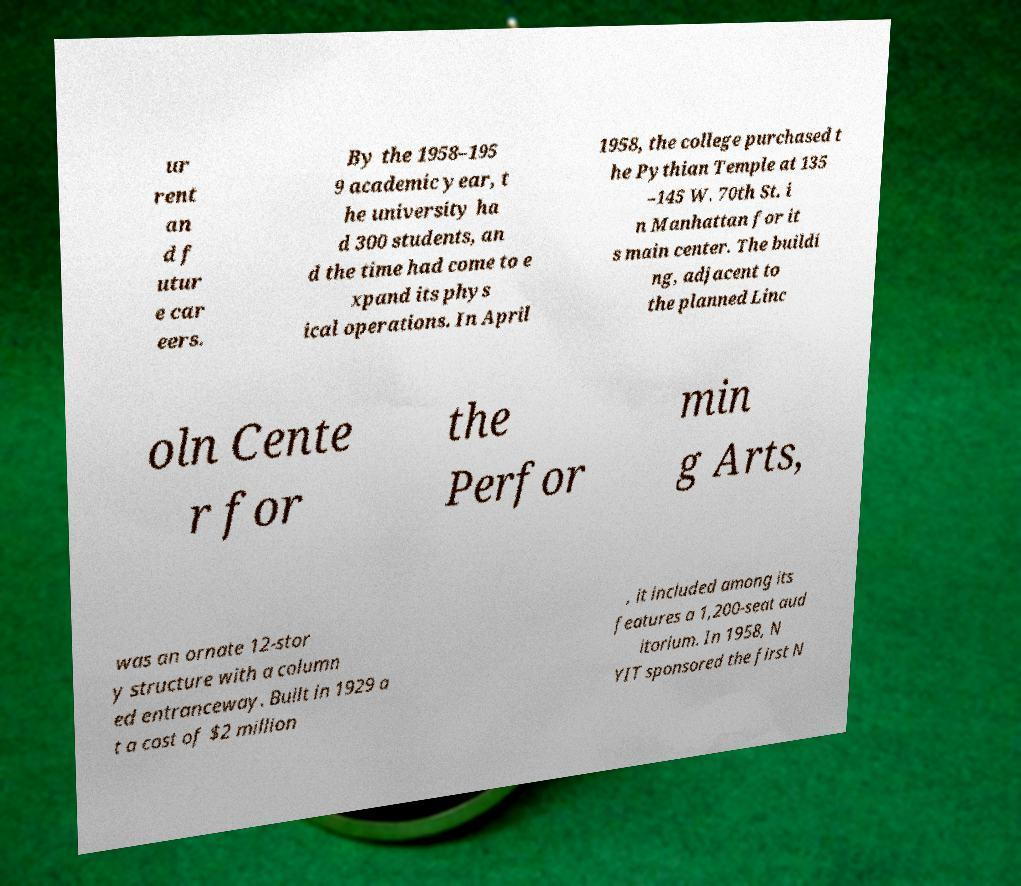What messages or text are displayed in this image? I need them in a readable, typed format. ur rent an d f utur e car eers. By the 1958–195 9 academic year, t he university ha d 300 students, an d the time had come to e xpand its phys ical operations. In April 1958, the college purchased t he Pythian Temple at 135 –145 W. 70th St. i n Manhattan for it s main center. The buildi ng, adjacent to the planned Linc oln Cente r for the Perfor min g Arts, was an ornate 12-stor y structure with a column ed entranceway. Built in 1929 a t a cost of $2 million , it included among its features a 1,200-seat aud itorium. In 1958, N YIT sponsored the first N 